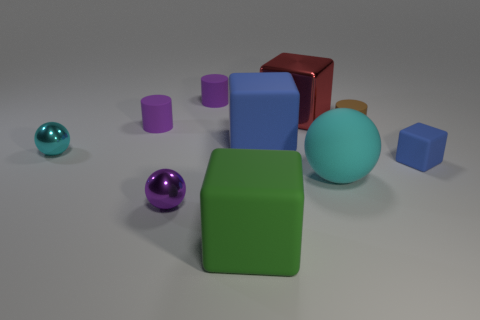Subtract 3 spheres. How many spheres are left? 0 Subtract all cyan balls. How many balls are left? 1 Subtract all cylinders. How many objects are left? 7 Subtract all cyan spheres. How many cyan cylinders are left? 0 Subtract all purple matte cylinders. Subtract all tiny purple rubber things. How many objects are left? 6 Add 7 large blue matte blocks. How many large blue matte blocks are left? 8 Add 7 small purple metal cubes. How many small purple metal cubes exist? 7 Subtract all brown cylinders. How many cylinders are left? 2 Subtract 0 yellow cylinders. How many objects are left? 10 Subtract all yellow cylinders. Subtract all brown spheres. How many cylinders are left? 3 